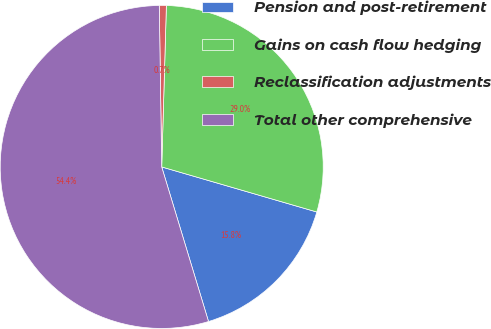Convert chart to OTSL. <chart><loc_0><loc_0><loc_500><loc_500><pie_chart><fcel>Pension and post-retirement<fcel>Gains on cash flow hedging<fcel>Reclassification adjustments<fcel>Total other comprehensive<nl><fcel>15.82%<fcel>29.04%<fcel>0.7%<fcel>54.44%<nl></chart> 